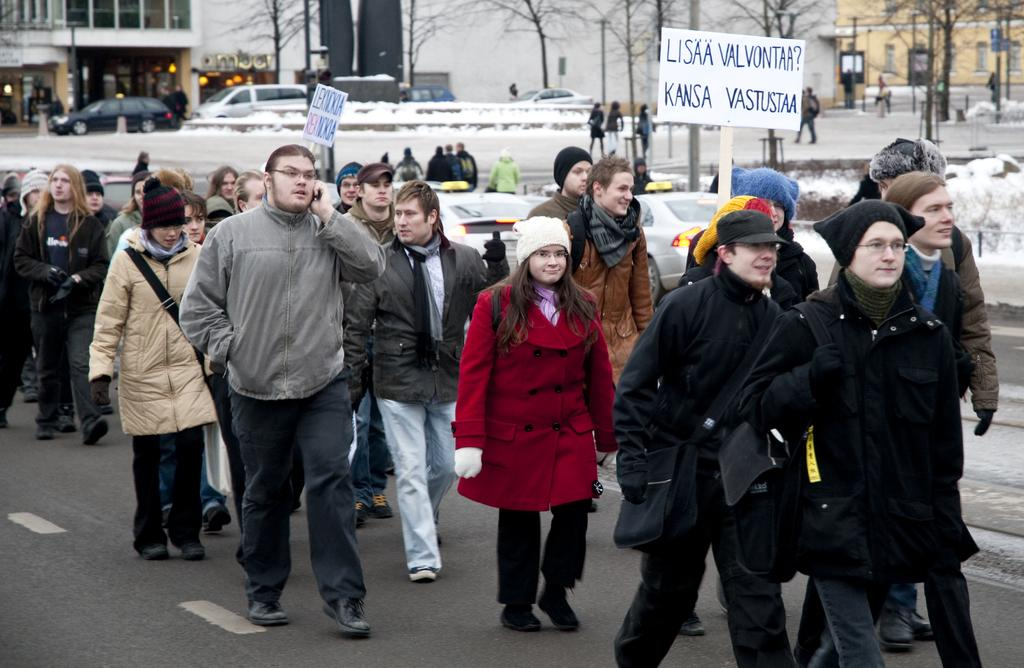What is happening on the road in the image? There are people on the road in the image, and some of them are holding placards. What else can be seen on the road? There are vehicles in the image. What structures are visible in the background? Electric poles, buildings, and trees are present in the image. What is the condition of the ground in the image? Snow is on the ground in the image. What organization is responsible for the sheep in the image? There are no sheep present in the image. Can you tell me how many people are driving in the image? There is no information about people driving in the image; it only shows people holding placards and vehicles on the road. 